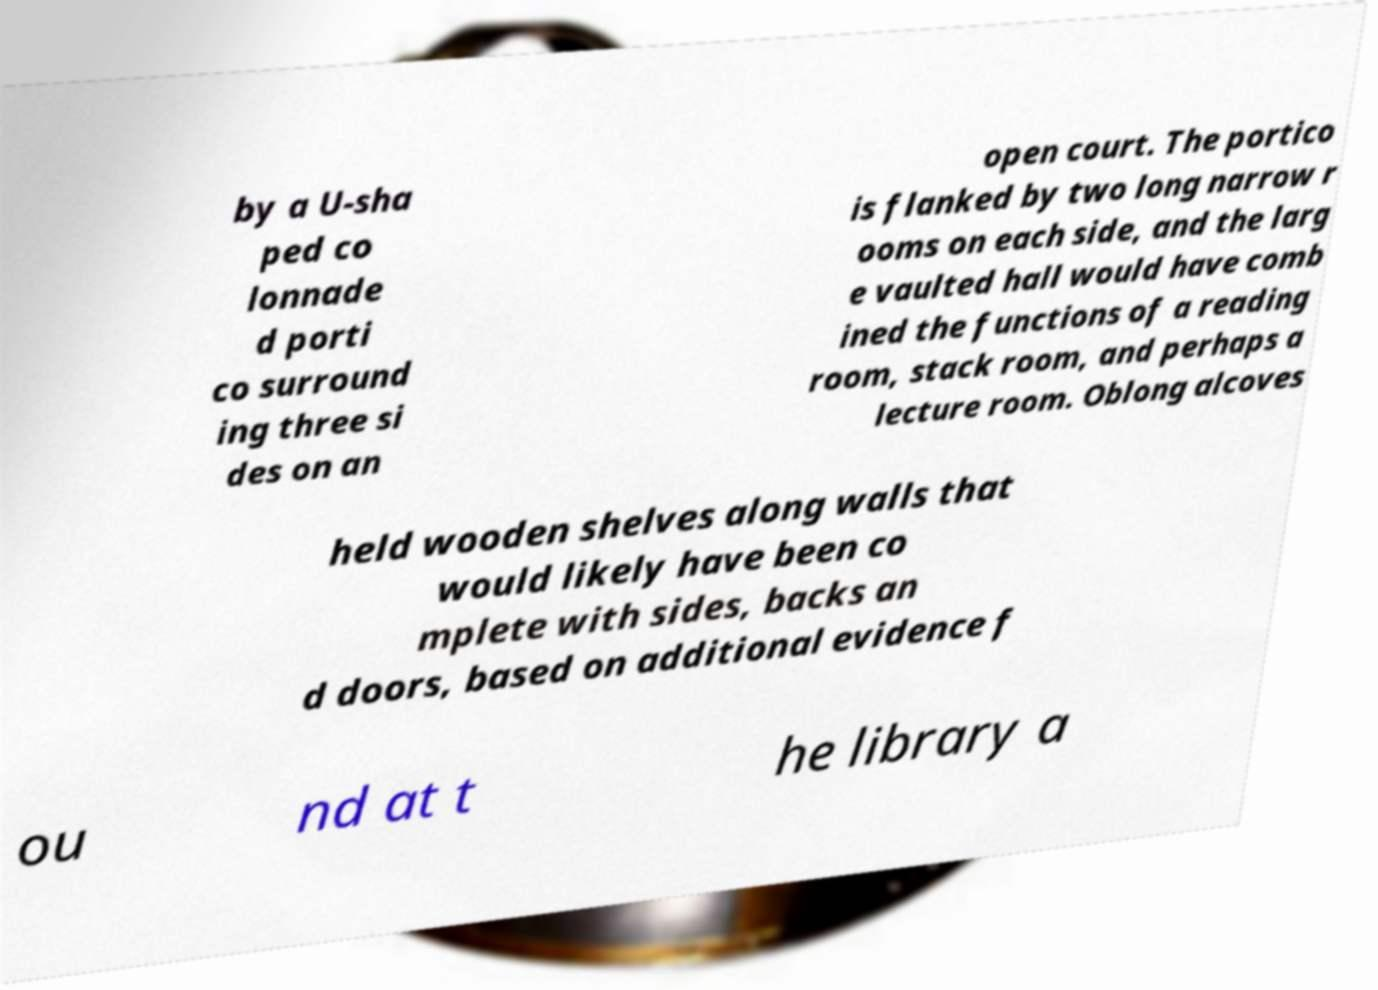Can you read and provide the text displayed in the image?This photo seems to have some interesting text. Can you extract and type it out for me? by a U-sha ped co lonnade d porti co surround ing three si des on an open court. The portico is flanked by two long narrow r ooms on each side, and the larg e vaulted hall would have comb ined the functions of a reading room, stack room, and perhaps a lecture room. Oblong alcoves held wooden shelves along walls that would likely have been co mplete with sides, backs an d doors, based on additional evidence f ou nd at t he library a 